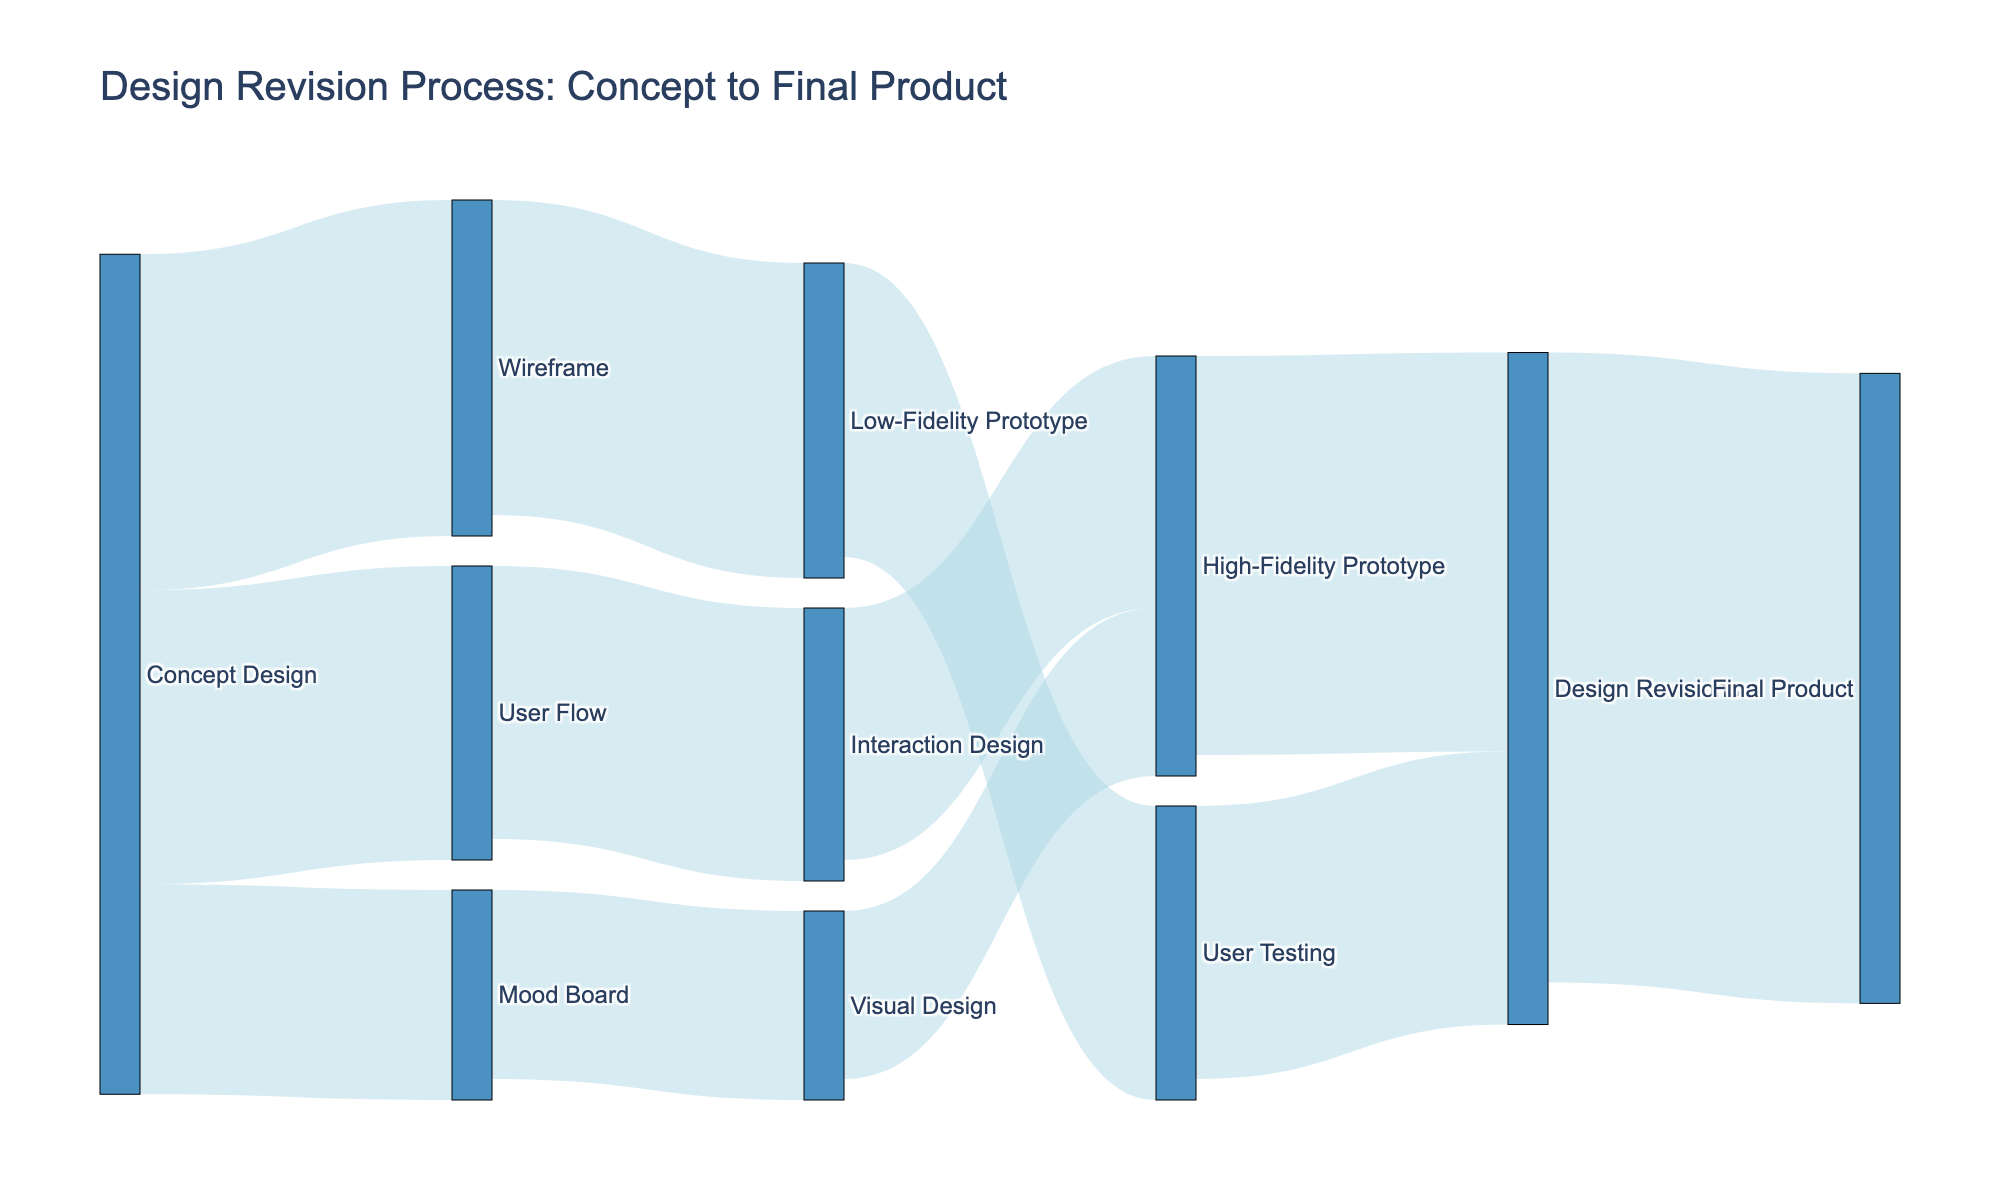What is the title of the Sankey diagram? The title of the diagram appears at the top and is generally the first piece of text you see in a plot. In this case, it is "Design Revision Process: Concept to Final Product".
Answer: "Design Revision Process: Concept to Final Product" How many different stages are shown in the diagram? You need to count the unique nodes in the diagram. These nodes are concepts like "Concept Design," "Wireframe," "Mood Board," etc. There are 11 unique nodes in total.
Answer: 11 Which transition has the highest value in the diagram? You need to look for the link with the largest numerical value attached. The highest value in the data is 150, which corresponds to "Design Revisions" to "Final Product".
Answer: Transition from "Design Revisions" to "Final Product" What stages come directly after "Concept Design"? Look for the nodes that are directly connected from "Concept Design" with arrows pointing away from it. These are "Wireframe" (80), "Mood Board" (50), and "User Flow" (70).
Answer: "Wireframe", "Mood Board", "User Flow" What is the total value flowing into "Design Revisions"? Sum the value of all incoming transitions to "Design Revisions". These transitions are from "User Testing" (70) and "High-Fidelity Prototype" (95), so the total is 70 + 95 = 165.
Answer: 165 Which node contributes the most towards the "Final Product"? Look at the values flowing into "Final Product." Since "Design Revisions" to "Final Product" is the only transition with the value of 150, it is the highest.
Answer: "Design Revisions" How many nodes have exactly two outgoing transitions? Identify nodes with exactly two connecting arrows leading away from them. "Concept Design" (3), "Wireframe" (1), "Mood Board" (1), and "User Flow" (1) each have more or less, leaving none with exactly 2.
Answer: 0 Which stage has more value coming in, "High-Fidelity Prototype" or "User Testing"? Compare the values of transitions flowing into them. "High-Fidelity Prototype" has incoming values of 40 (from "Visual Design") and 60 (from "Interaction Design"), totaling 100. "User Testing" has one value of 70 (from "Low-Fidelity Prototype"). 100 is greater than 70.
Answer: "High-Fidelity Prototype" What is the total value flowing out of "Wireframe"? The only transition from "Wireframe" is to "Low-Fidelity Prototype" with a value of 75.
Answer: 75 